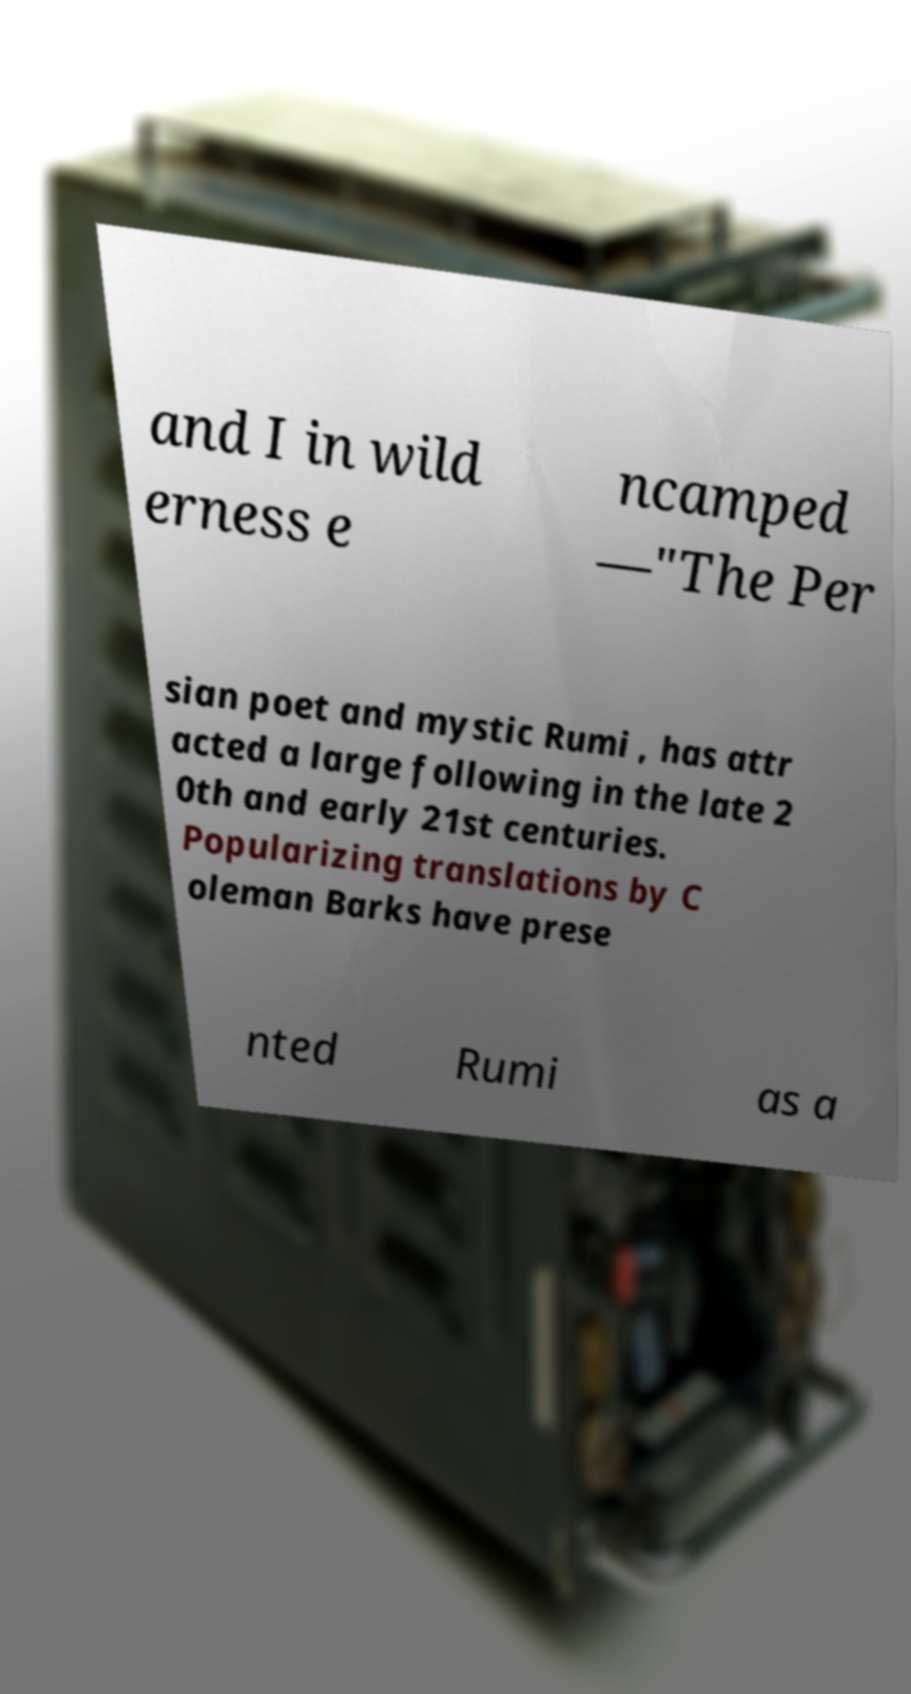For documentation purposes, I need the text within this image transcribed. Could you provide that? and I in wild erness e ncamped —"The Per sian poet and mystic Rumi , has attr acted a large following in the late 2 0th and early 21st centuries. Popularizing translations by C oleman Barks have prese nted Rumi as a 